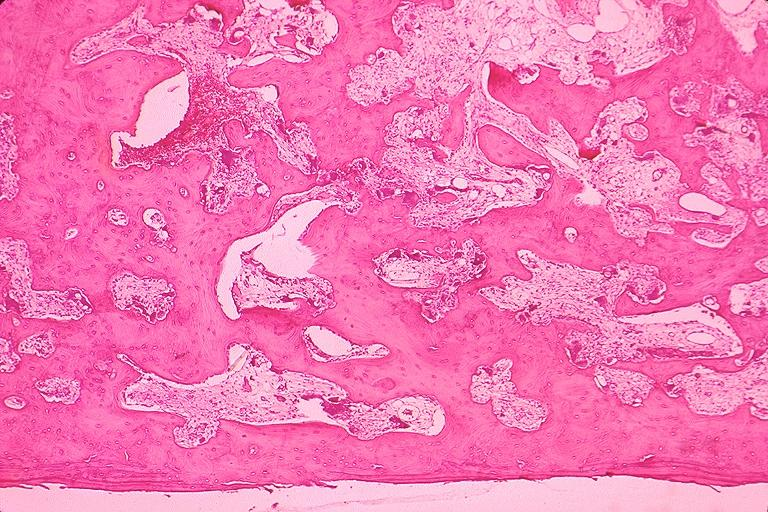does mucicarmine show pagets disease?
Answer the question using a single word or phrase. No 